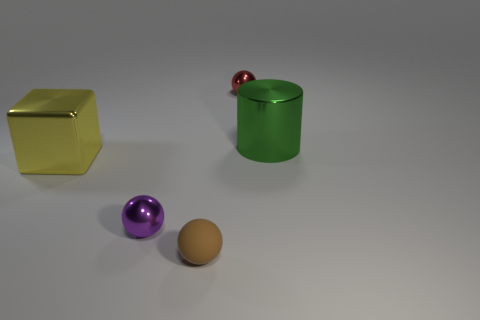Add 3 large metal cylinders. How many objects exist? 8 Subtract all cylinders. How many objects are left? 4 Subtract 0 gray blocks. How many objects are left? 5 Subtract all large metal objects. Subtract all tiny things. How many objects are left? 0 Add 5 large green shiny cylinders. How many large green shiny cylinders are left? 6 Add 3 big green objects. How many big green objects exist? 4 